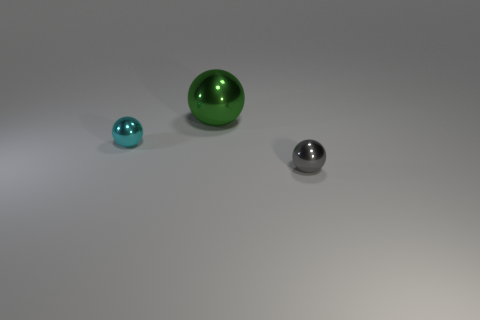What kind of setting or context can you deduce from this scene? The image seems to be set in a minimalistic environment, likely a controlled setup used to highlight the objects' characteristics without any distractions. The background is neutral and there are slight shadows beneath the spheres, suggesting a light source nearby. This type of setting is commonly used in product photography, 3D modeling, and artistic displays to focus attention on the items and their features. 